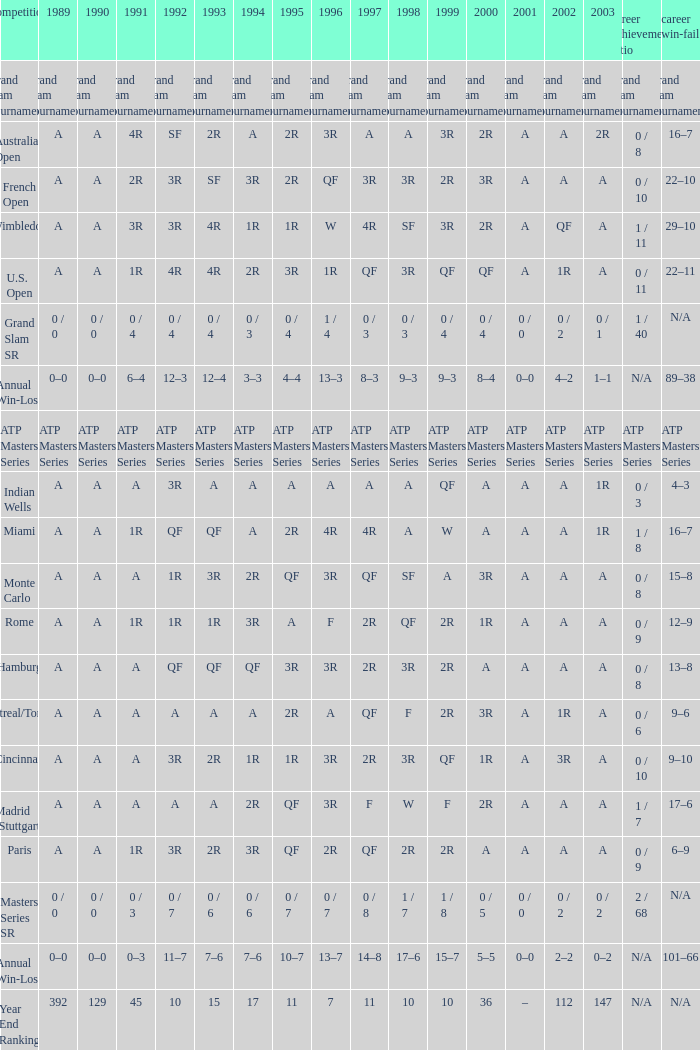What was the career SR with a value of A in 1980 and F in 1997? 1 / 7. 